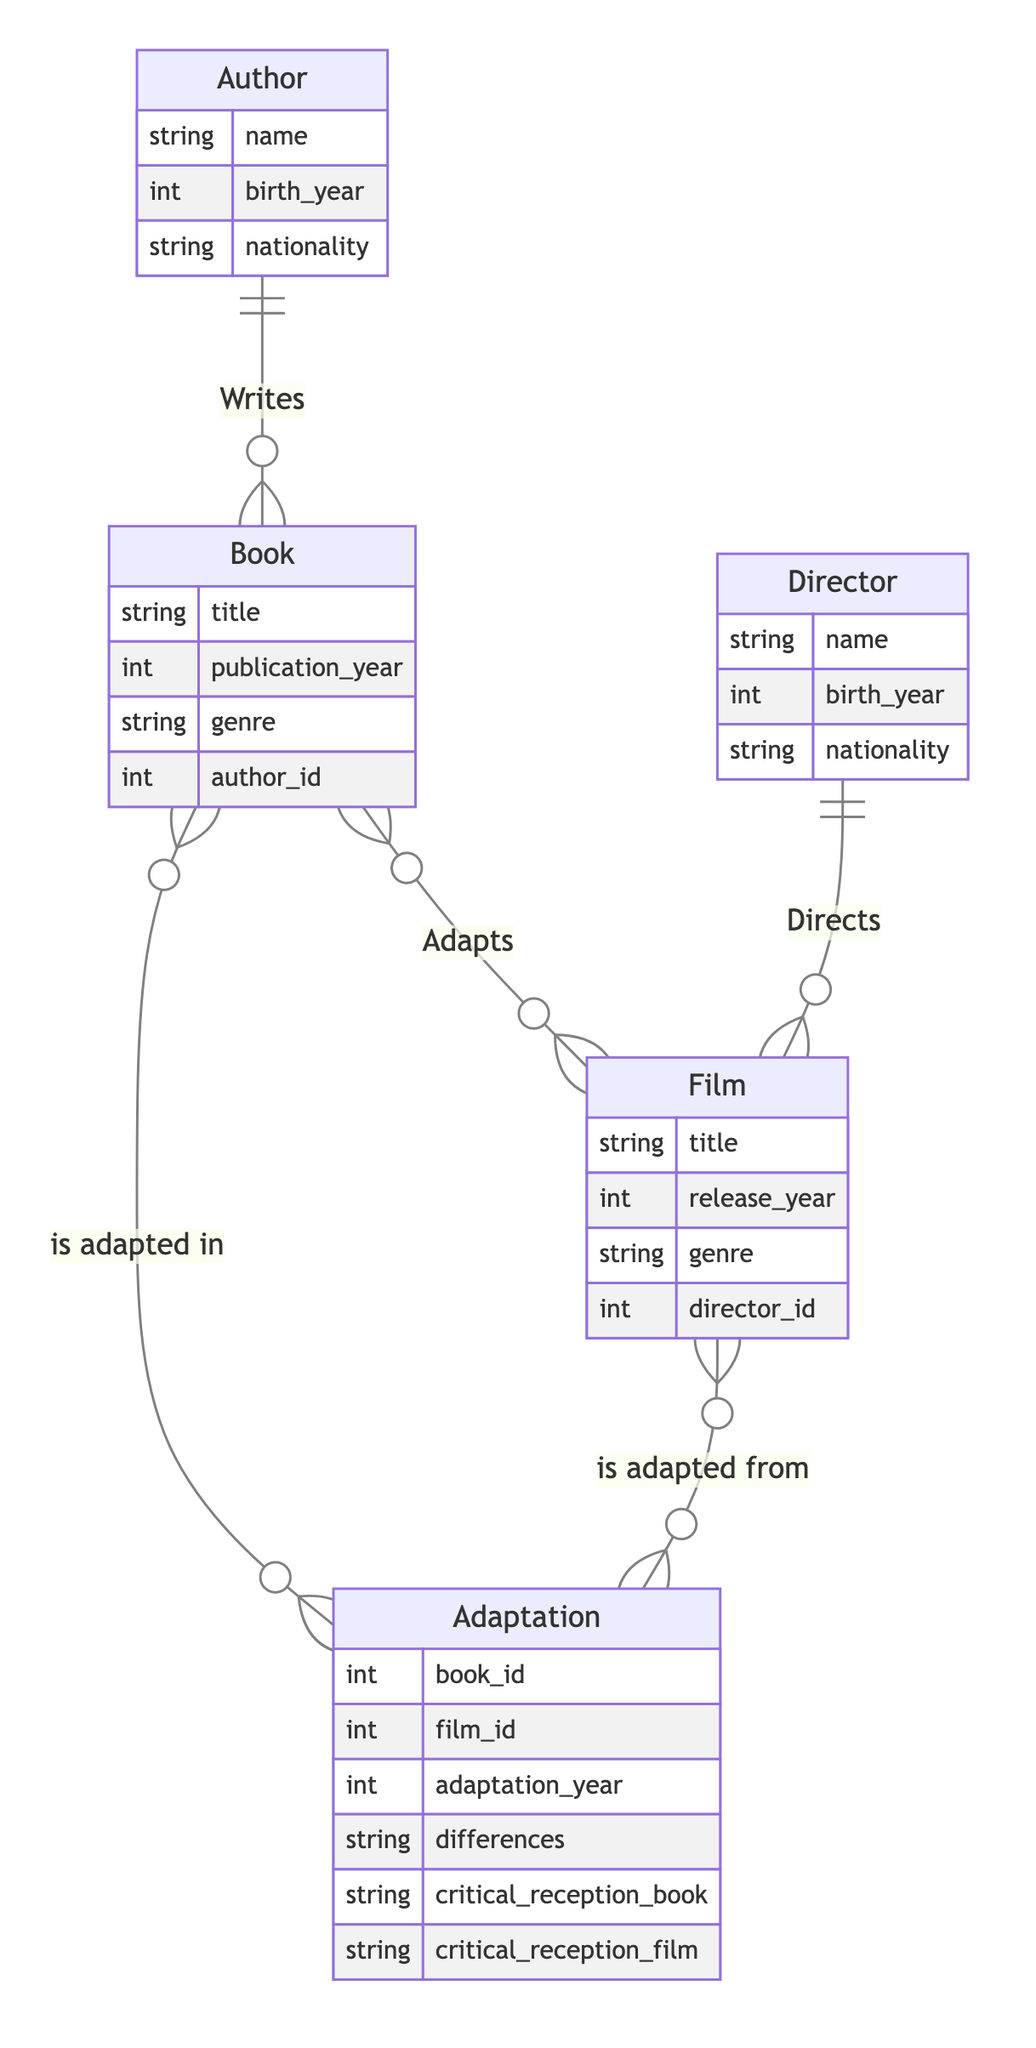What is the title of the book written by Marcel Proust? The diagram indicates that Marcel Proust is the author of "In Search of Lost Time." This relationship can be traced through the "Writes" connection between the Author and Book entities.
Answer: In Search of Lost Time Who directed the film "Dangerous Liaisons"? The "Director" entity shows that "Dangerous Liaisons" was directed by Stephen Frears, as indicated by the connecting relationship from the Film entity to the Director entity.
Answer: Stephen Frears How many authors are represented in the diagram? The diagram lists two distinct Author entities (Marcel Proust and Pierre Choderlos de Laclos), which can be easily counted.
Answer: 2 What year was the film adaptation of "In Search of Lost Time" released? The adaptation data shows that the film "Time Regained," which adapts "In Search of Lost Time," was released in 1999. This information is accessed through the Adaptation relationship, which links the Book and Film entities.
Answer: 1999 What adaptations were made to modernize "Dangerous Liaisons"? The adaptation details state that it modernized certain aspects to appeal to contemporary audiences. The "differences" attribute in the Adaptation entity conveys these changes.
Answer: Modernized certain aspects What is the genre of the book "Dangerous Liaisons"? The Book entity for "Dangerous Liaisons" specifies that its genre is "Epistolary novel," which can be directly retrieved from the attributes of the Book entity.
Answer: Epistolary novel What is the critical reception of the film adaptation of "Dangerous Liaisons"? According to the adaptation information, the film version of "Dangerous Liaisons" was "Critically acclaimed and won several awards," which is stated in the critical reception attribute of the Adaptation entity.
Answer: Critically acclaimed and won several awards Which author has a birth year of 1871? The Author entity clearly shows that Marcel Proust, who wrote "In Search of Lost Time," was born in 1871. Thus, this information can be directly linked to the Author entity.
Answer: Marcel Proust What do the relationships in the diagram indicate about the connection between books and films? The relationships show that books can adapt into films and vice versa, as indicated by the "Adapts" relationships which are many-to-many, allowing for multiple adaptations between various books and films.
Answer: Many-to-many adaptations 